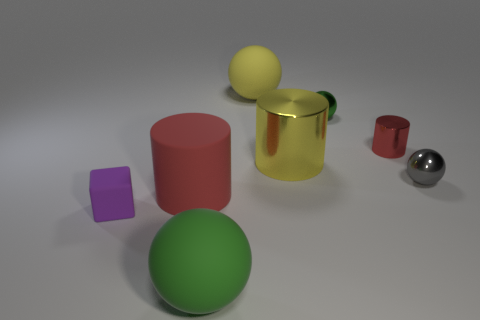There is a big matte object that is the same color as the tiny cylinder; what is its shape?
Your response must be concise. Cylinder. There is a small thing left of the large green matte thing; is there a red metal cylinder that is behind it?
Your response must be concise. Yes. What number of things are both behind the gray metallic thing and on the left side of the tiny red object?
Keep it short and to the point. 3. How many large yellow balls have the same material as the cube?
Your answer should be compact. 1. There is a shiny cylinder that is to the right of the small green metallic object that is behind the big red cylinder; how big is it?
Provide a short and direct response. Small. Is there a big red rubber object of the same shape as the purple matte object?
Ensure brevity in your answer.  No. Is the size of the red object right of the tiny green metal object the same as the matte sphere behind the green matte thing?
Provide a short and direct response. No. Is the number of cylinders in front of the red matte thing less than the number of tiny gray spheres to the right of the tiny metallic cylinder?
Ensure brevity in your answer.  Yes. What is the material of the other cylinder that is the same color as the large rubber cylinder?
Make the answer very short. Metal. What color is the tiny metallic object to the right of the tiny red metallic cylinder?
Your response must be concise. Gray. 